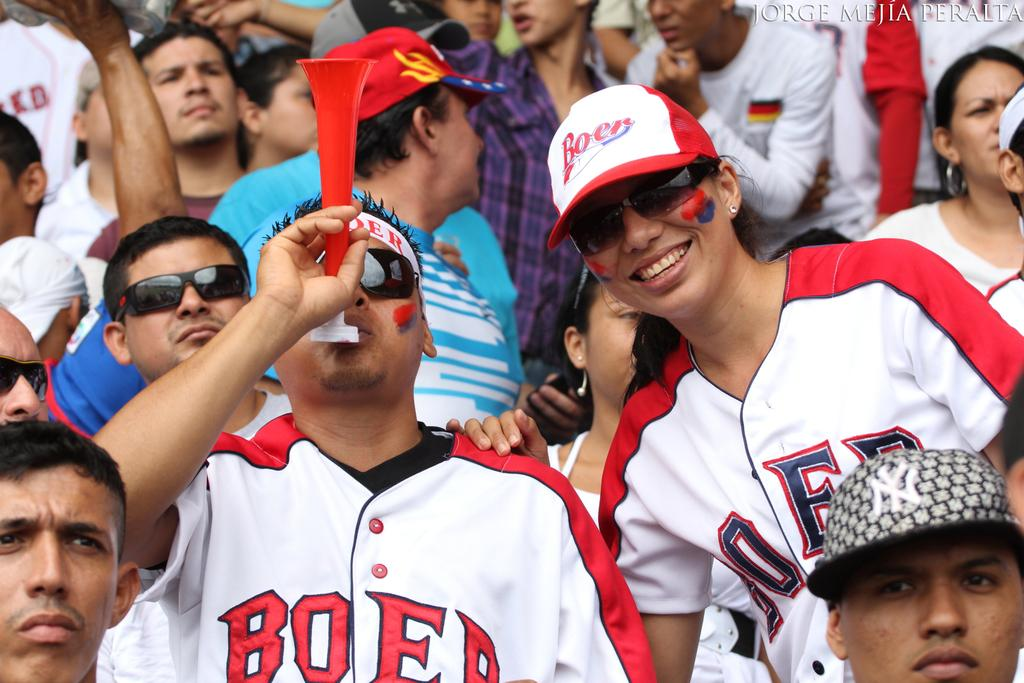<image>
Share a concise interpretation of the image provided. A crowd is at a sports game and some are wearing baseball shirts that say Boer. 